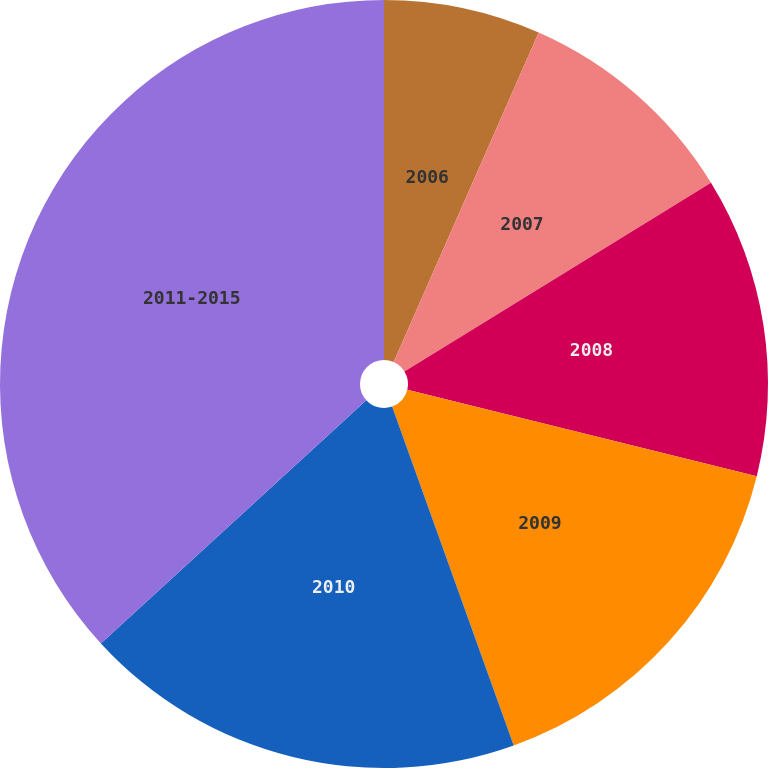Convert chart. <chart><loc_0><loc_0><loc_500><loc_500><pie_chart><fcel>2006<fcel>2007<fcel>2008<fcel>2009<fcel>2010<fcel>2011-2015<nl><fcel>6.6%<fcel>9.62%<fcel>12.64%<fcel>15.66%<fcel>18.68%<fcel>36.81%<nl></chart> 